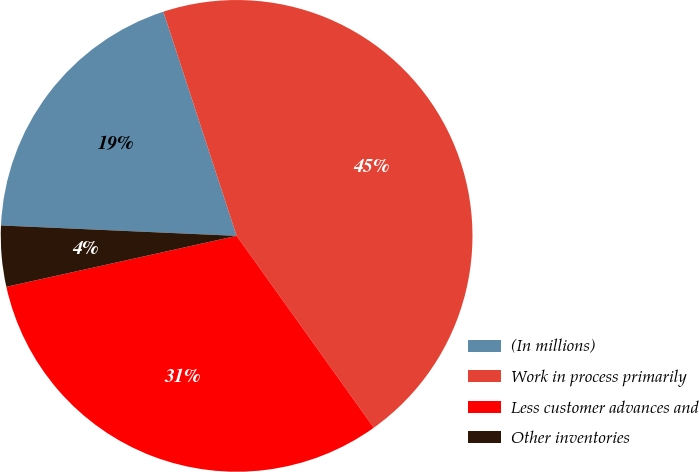Convert chart to OTSL. <chart><loc_0><loc_0><loc_500><loc_500><pie_chart><fcel>(In millions)<fcel>Work in process primarily<fcel>Less customer advances and<fcel>Other inventories<nl><fcel>19.27%<fcel>45.15%<fcel>31.41%<fcel>4.17%<nl></chart> 